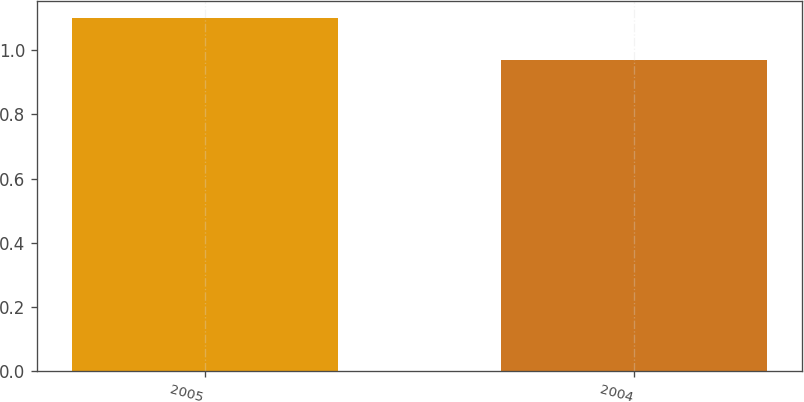Convert chart to OTSL. <chart><loc_0><loc_0><loc_500><loc_500><bar_chart><fcel>2005<fcel>2004<nl><fcel>1.1<fcel>0.97<nl></chart> 